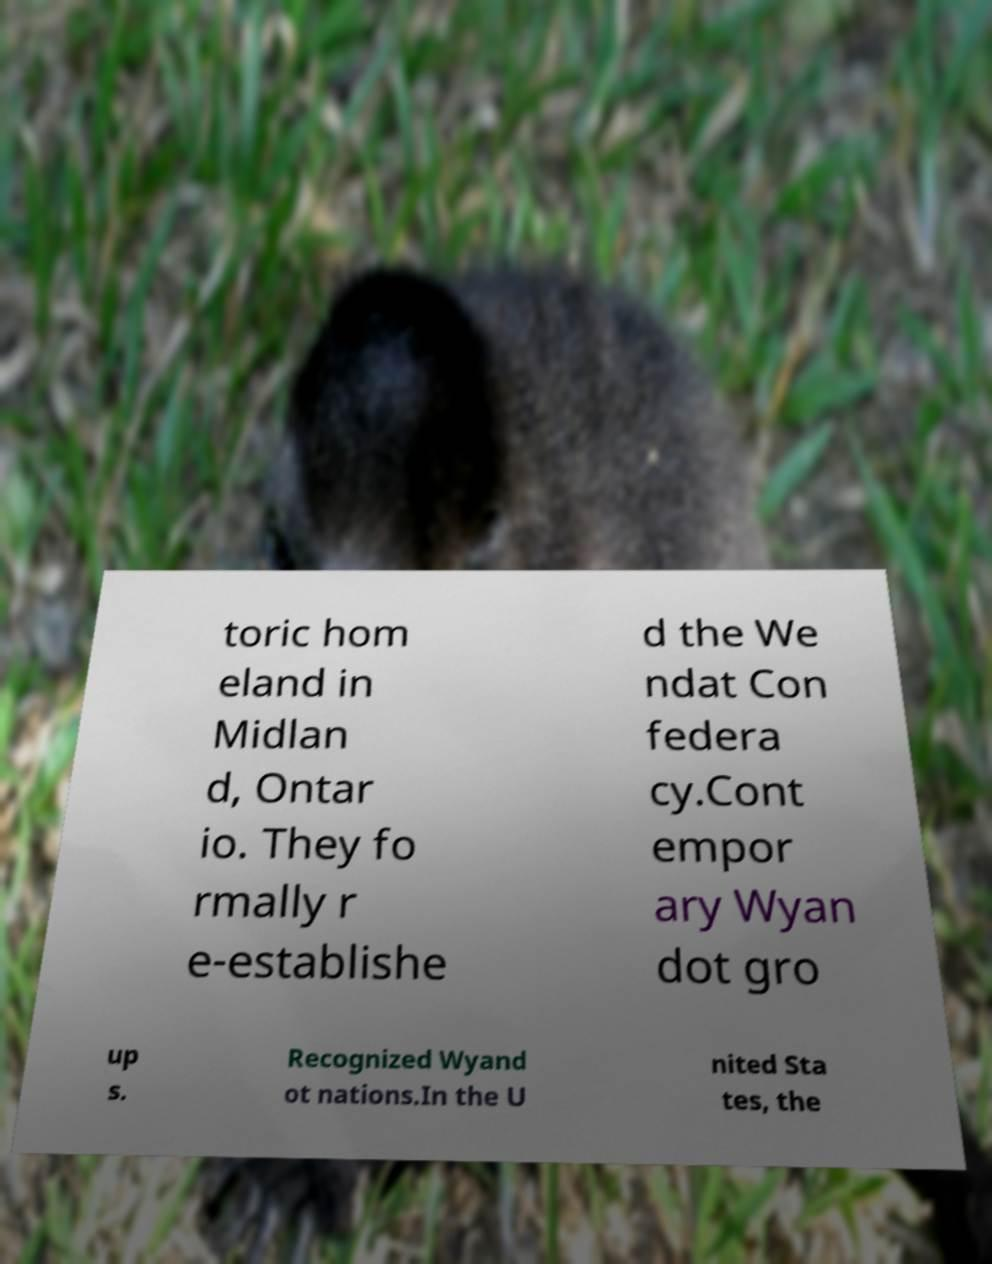Please identify and transcribe the text found in this image. toric hom eland in Midlan d, Ontar io. They fo rmally r e-establishe d the We ndat Con federa cy.Cont empor ary Wyan dot gro up s. Recognized Wyand ot nations.In the U nited Sta tes, the 